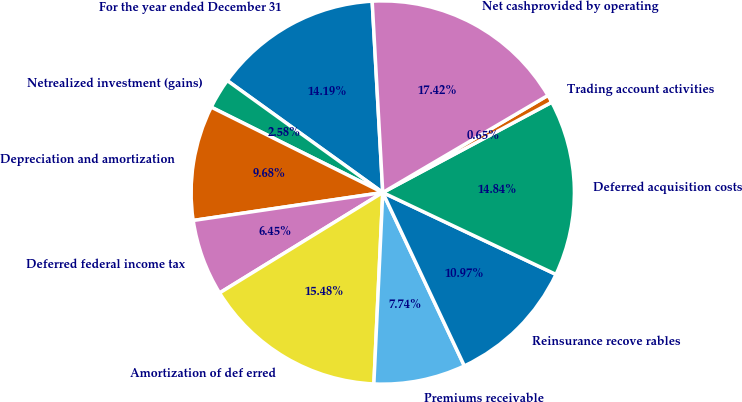Convert chart. <chart><loc_0><loc_0><loc_500><loc_500><pie_chart><fcel>For the year ended December 31<fcel>Netrealized investment (gains)<fcel>Depreciation and amortization<fcel>Deferred federal income tax<fcel>Amortization of def erred<fcel>Premiums receivable<fcel>Reinsurance recove rables<fcel>Deferred acquisition costs<fcel>Trading account activities<fcel>Net cashprovided by operating<nl><fcel>14.19%<fcel>2.58%<fcel>9.68%<fcel>6.45%<fcel>15.48%<fcel>7.74%<fcel>10.97%<fcel>14.84%<fcel>0.65%<fcel>17.42%<nl></chart> 